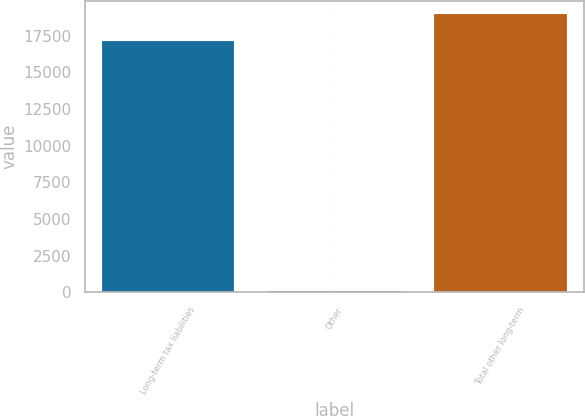Convert chart. <chart><loc_0><loc_0><loc_500><loc_500><bar_chart><fcel>Long-term tax liabilities<fcel>Other<fcel>Total other long-term<nl><fcel>17163<fcel>57<fcel>18955.4<nl></chart> 